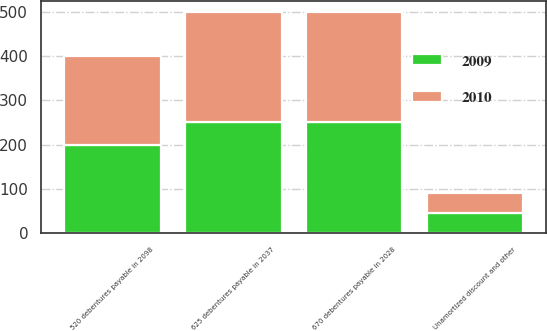Convert chart. <chart><loc_0><loc_0><loc_500><loc_500><stacked_bar_chart><ecel><fcel>670 debentures payable in 2028<fcel>625 debentures payable in 2037<fcel>520 debentures payable in 2098<fcel>Unamortized discount and other<nl><fcel>2010<fcel>250<fcel>250<fcel>200<fcel>45.1<nl><fcel>2009<fcel>250<fcel>250<fcel>200<fcel>45.3<nl></chart> 